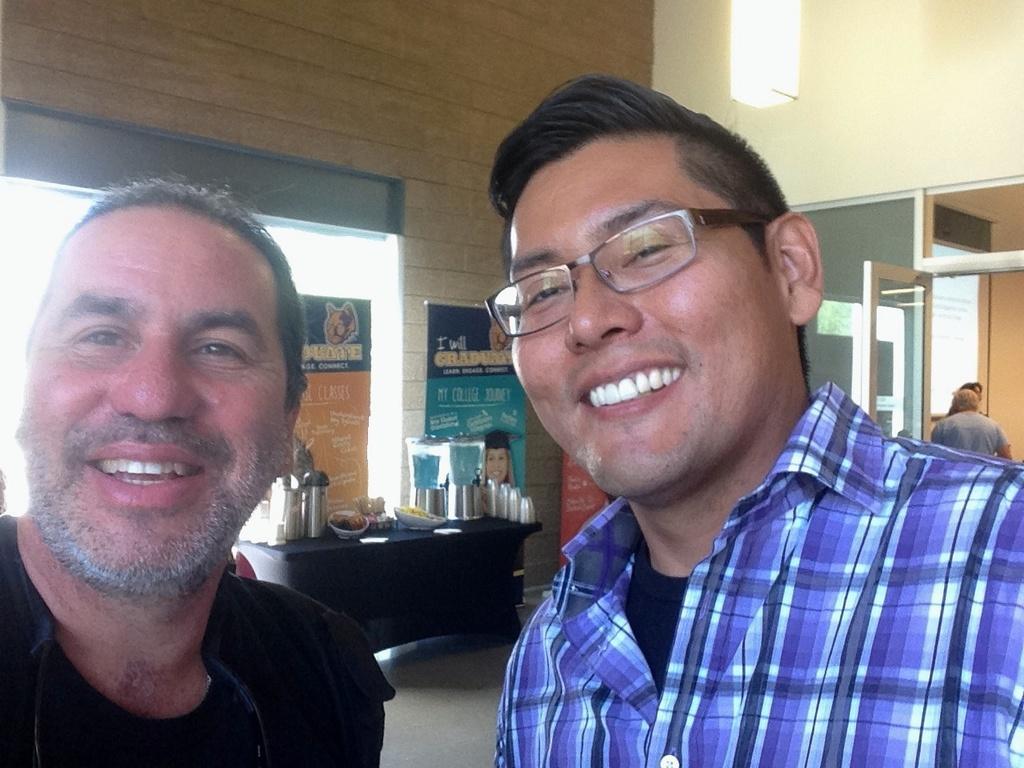Describe this image in one or two sentences. In this image we can see two people on the floor. On the backside we can see a wall, window and some glasses and jars placed on a table. We can also see a person beside a door and a ceiling light. 